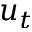Convert formula to latex. <formula><loc_0><loc_0><loc_500><loc_500>u _ { t }</formula> 